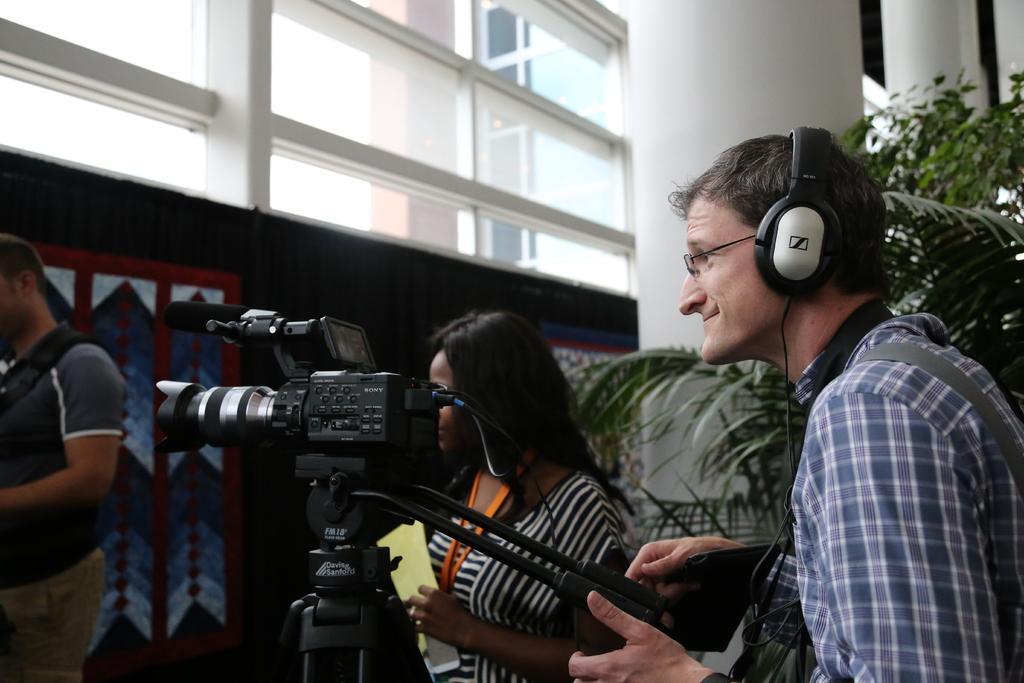In one or two sentences, can you explain what this image depicts? This picture shows a man standing on the right and he wore a headset on the head and he is holding a camera and i see camera to the stand and a woman standing on the side holding papers in her hands and i see another man on the left side in front of the camera and i see a wall and glasses to it on the top, From the glass we see another buildings and I see plants on the right side of the man holding camera. 